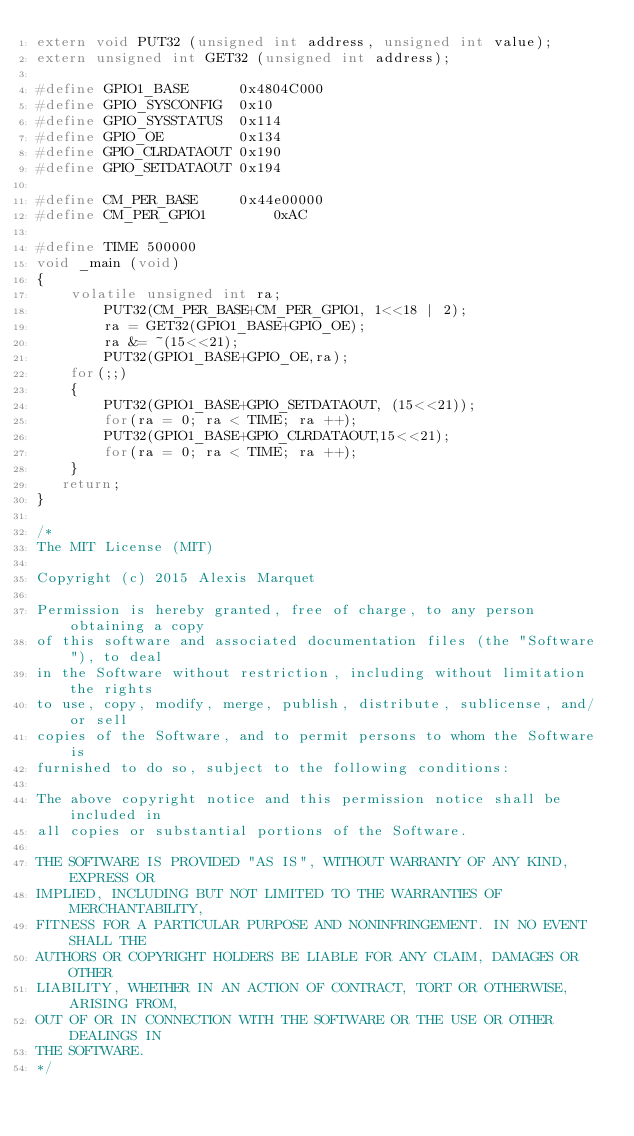Convert code to text. <code><loc_0><loc_0><loc_500><loc_500><_C_>extern void PUT32 (unsigned int address, unsigned int value);
extern unsigned int GET32 (unsigned int address);

#define GPIO1_BASE		0x4804C000
#define GPIO_SYSCONFIG	0x10
#define GPIO_SYSSTATUS	0x114
#define GPIO_OE			0x134
#define GPIO_CLRDATAOUT	0x190
#define GPIO_SETDATAOUT	0x194

#define CM_PER_BASE		0x44e00000
#define CM_PER_GPIO1		0xAC

#define TIME 500000
void _main (void)
{
	volatile unsigned int ra;
		PUT32(CM_PER_BASE+CM_PER_GPIO1, 1<<18 | 2);
		ra = GET32(GPIO1_BASE+GPIO_OE);
		ra &= ~(15<<21);
		PUT32(GPIO1_BASE+GPIO_OE,ra);
	for(;;)
	{
		PUT32(GPIO1_BASE+GPIO_SETDATAOUT, (15<<21));
		for(ra = 0; ra < TIME; ra ++);
		PUT32(GPIO1_BASE+GPIO_CLRDATAOUT,15<<21);
		for(ra = 0; ra < TIME; ra ++);
	}
   return;
}

/*
The MIT License (MIT)

Copyright (c) 2015 Alexis Marquet

Permission is hereby granted, free of charge, to any person obtaining a copy
of this software and associated documentation files (the "Software"), to deal
in the Software without restriction, including without limitation the rights
to use, copy, modify, merge, publish, distribute, sublicense, and/or sell
copies of the Software, and to permit persons to whom the Software is
furnished to do so, subject to the following conditions:

The above copyright notice and this permission notice shall be included in
all copies or substantial portions of the Software.

THE SOFTWARE IS PROVIDED "AS IS", WITHOUT WARRANTY OF ANY KIND, EXPRESS OR
IMPLIED, INCLUDING BUT NOT LIMITED TO THE WARRANTIES OF MERCHANTABILITY,
FITNESS FOR A PARTICULAR PURPOSE AND NONINFRINGEMENT. IN NO EVENT SHALL THE
AUTHORS OR COPYRIGHT HOLDERS BE LIABLE FOR ANY CLAIM, DAMAGES OR OTHER
LIABILITY, WHETHER IN AN ACTION OF CONTRACT, TORT OR OTHERWISE, ARISING FROM,
OUT OF OR IN CONNECTION WITH THE SOFTWARE OR THE USE OR OTHER DEALINGS IN
THE SOFTWARE.
*/
</code> 